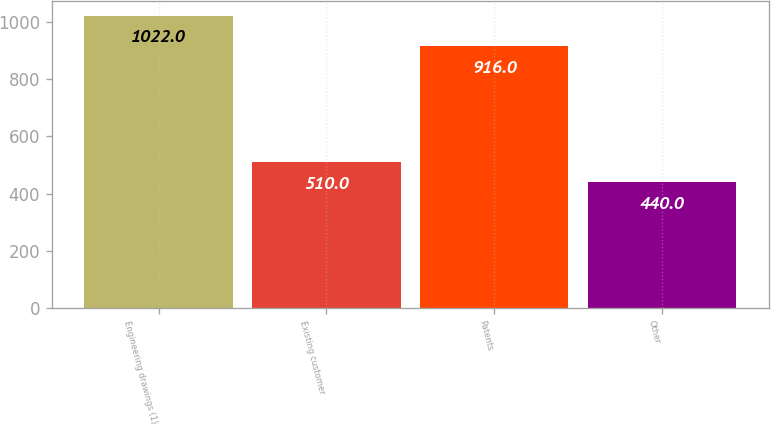Convert chart to OTSL. <chart><loc_0><loc_0><loc_500><loc_500><bar_chart><fcel>Engineering drawings (1)<fcel>Existing customer<fcel>Patents<fcel>Other<nl><fcel>1022<fcel>510<fcel>916<fcel>440<nl></chart> 